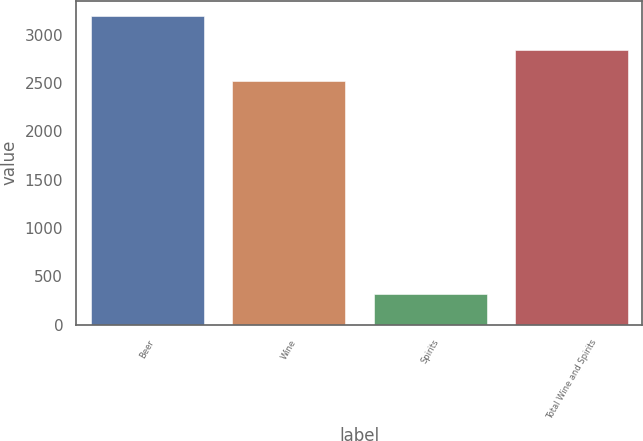Convert chart. <chart><loc_0><loc_0><loc_500><loc_500><bar_chart><fcel>Beer<fcel>Wine<fcel>Spirits<fcel>Total Wine and Spirits<nl><fcel>3188.6<fcel>2523.4<fcel>316<fcel>2839.4<nl></chart> 